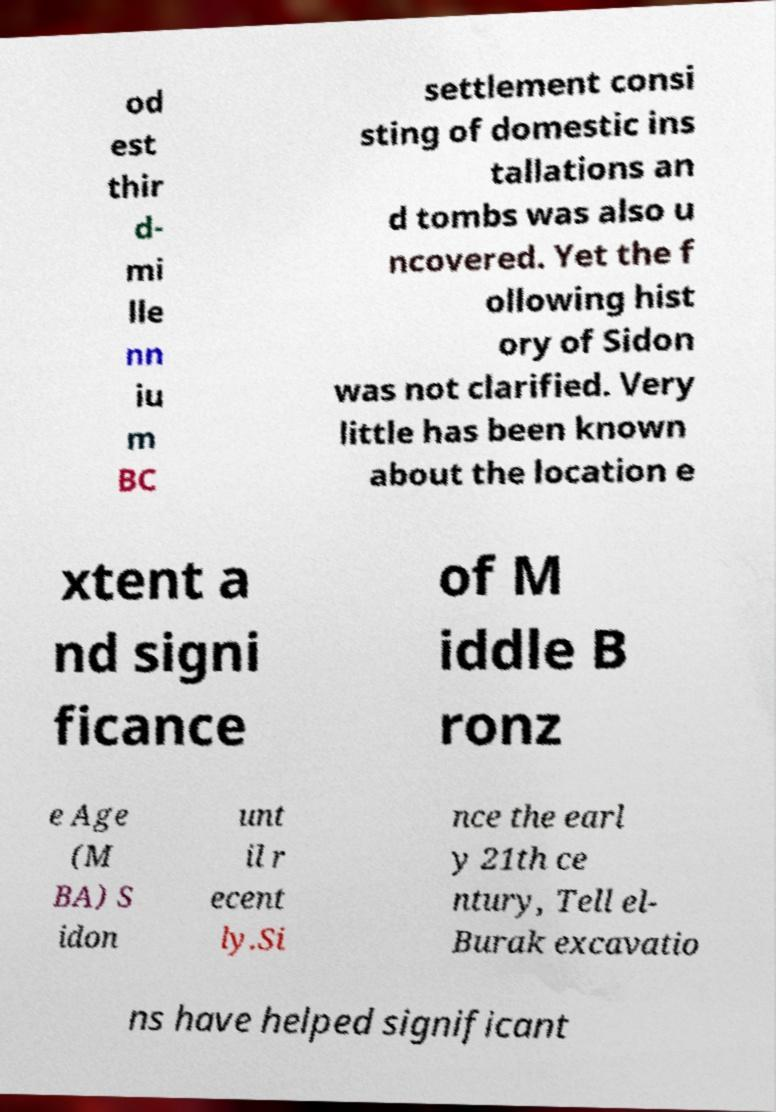For documentation purposes, I need the text within this image transcribed. Could you provide that? od est thir d- mi lle nn iu m BC settlement consi sting of domestic ins tallations an d tombs was also u ncovered. Yet the f ollowing hist ory of Sidon was not clarified. Very little has been known about the location e xtent a nd signi ficance of M iddle B ronz e Age (M BA) S idon unt il r ecent ly.Si nce the earl y 21th ce ntury, Tell el- Burak excavatio ns have helped significant 